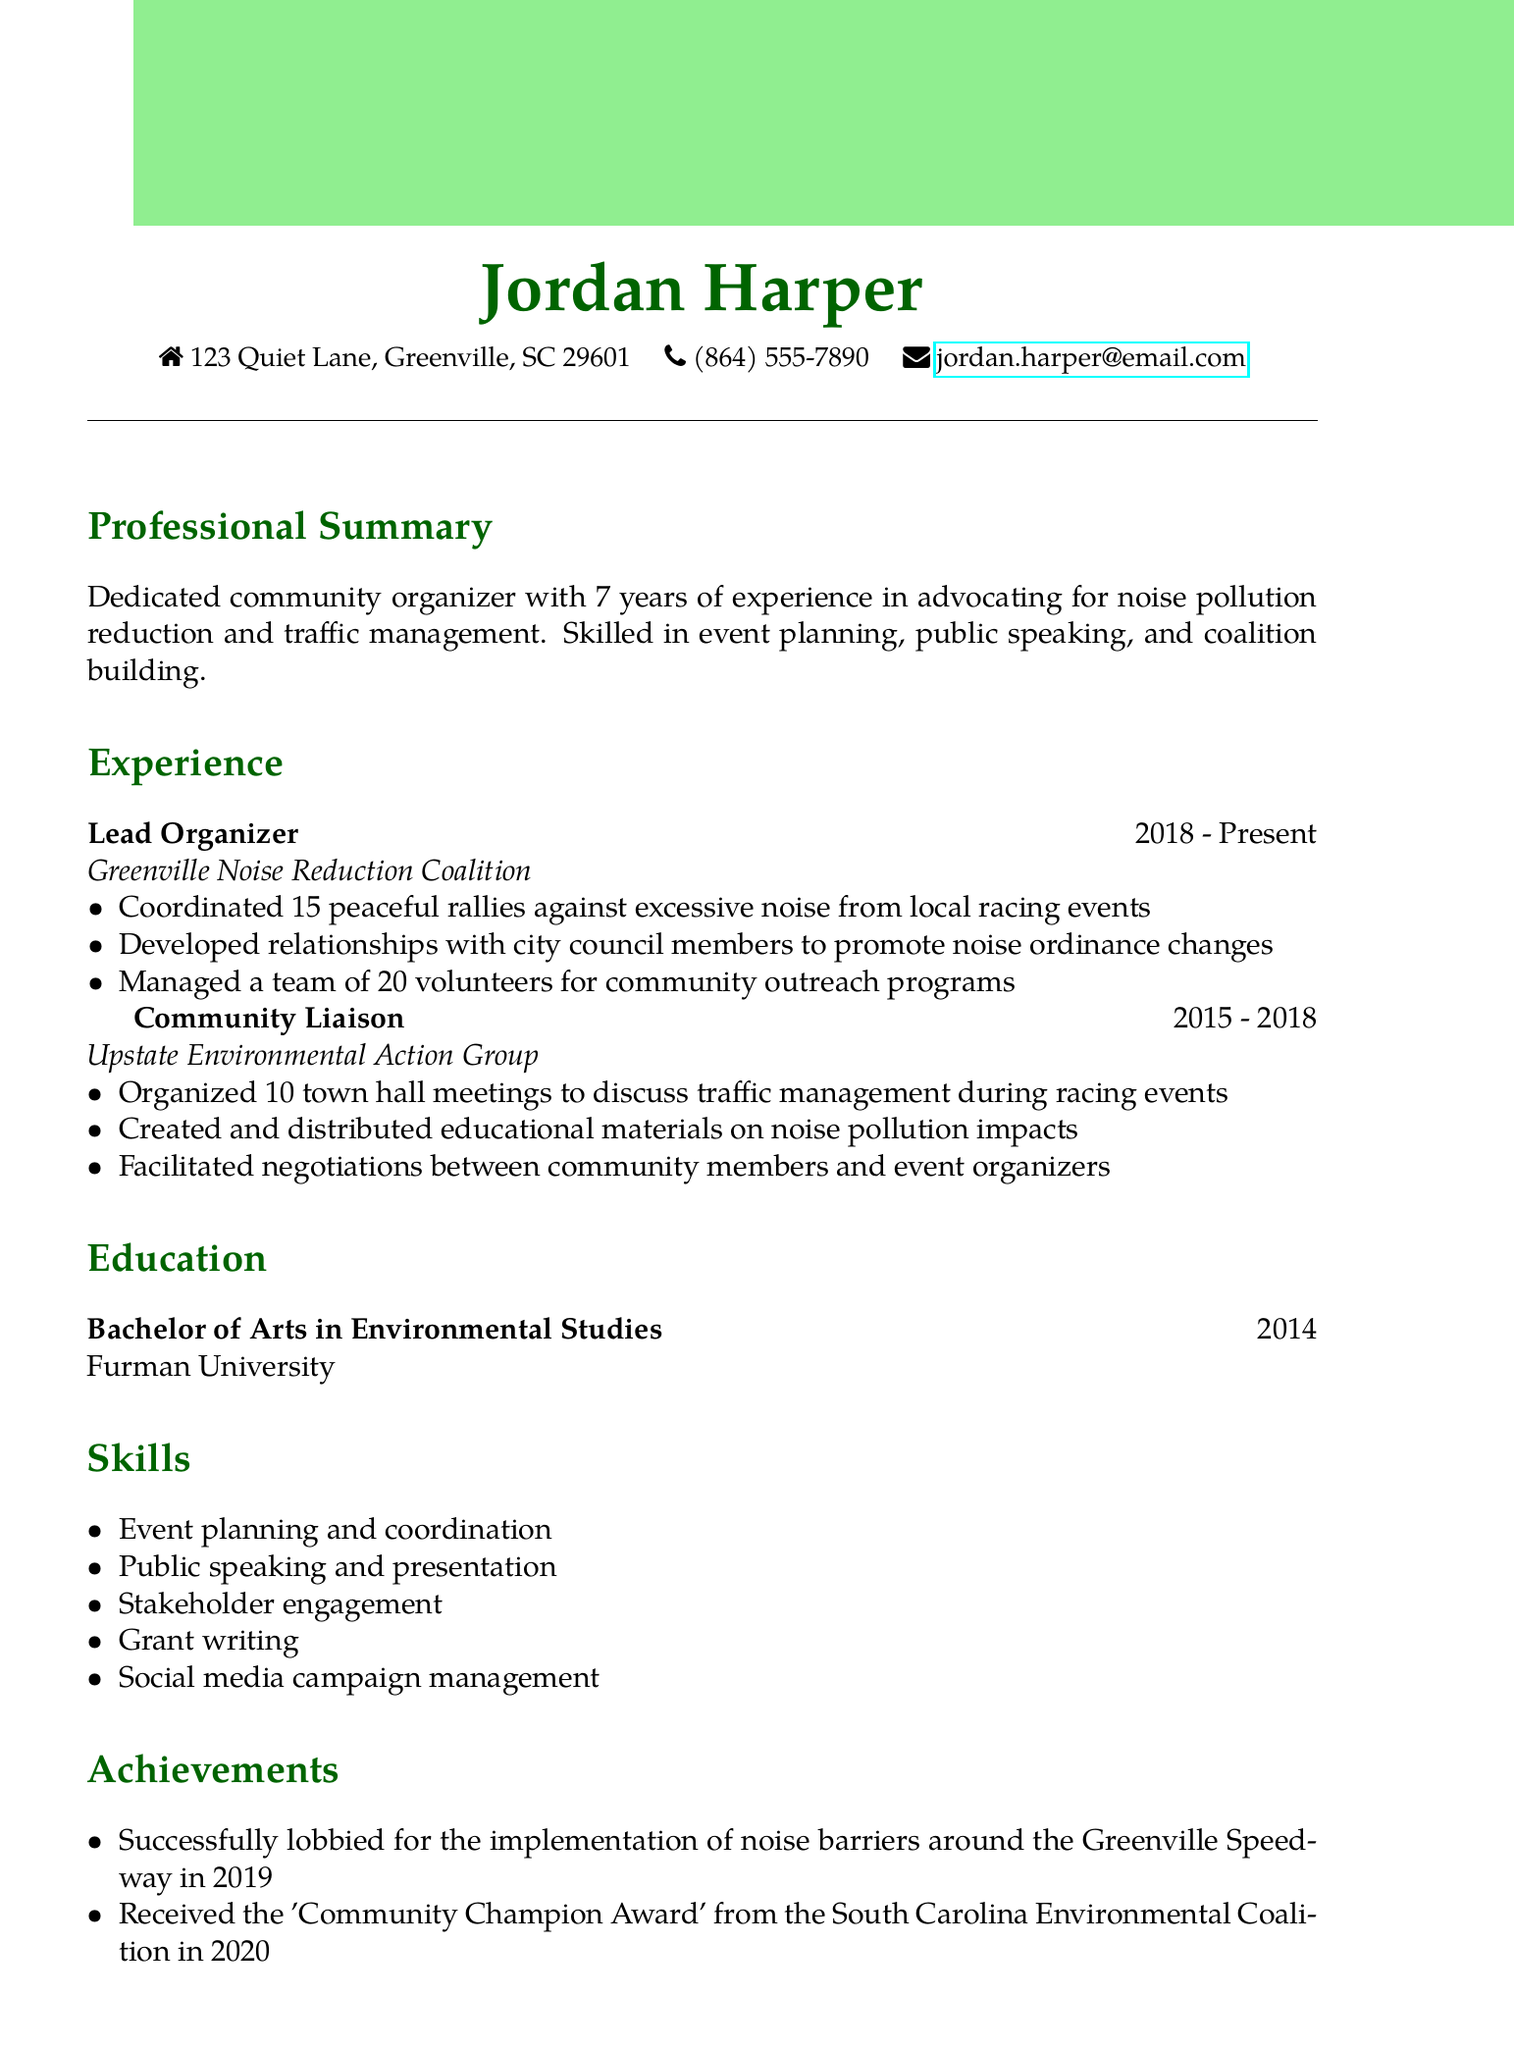What is the name of the individual? The name of the individual is stated at the top of the document as "Jordan Harper."
Answer: Jordan Harper What is the role of Jordan Harper at the Greenville Noise Reduction Coalition? The document mentions Jordan Harper's title at the Greenville Noise Reduction Coalition, which is "Lead Organizer."
Answer: Lead Organizer How many rallies has Jordan Harper coordinated? The document specifies that Jordan Harper coordinated "15 peaceful rallies against excessive noise from local racing events."
Answer: 15 What degree did Jordan Harper obtain? The education section indicates that Jordan Harper holds a "Bachelor of Arts in Environmental Studies."
Answer: Bachelor of Arts in Environmental Studies In what year did Jordan Harper graduate? The document notes that Jordan Harper graduated in "2014."
Answer: 2014 Which award did Jordan Harper receive in 2020? The achievements section lists the award as the "'Community Champion Award' from the South Carolina Environmental Coalition."
Answer: Community Champion Award How long has Jordan Harper been a Board Member of Quiet Communities of America? The volunteer work section states the duration as "2017 - Present," implying a timeframe of approximately 6 years.
Answer: 6 years What organization did Jordan Harper work for prior to the Greenville Noise Reduction Coalition? The document states that before the current position, Jordan Harper worked for the "Upstate Environmental Action Group."
Answer: Upstate Environmental Action Group What are two skills listed in the CV? The skills section enumerates various skills, and one example is "Event planning and coordination," along with other skills.
Answer: Event planning and coordination; Public speaking and presentation 